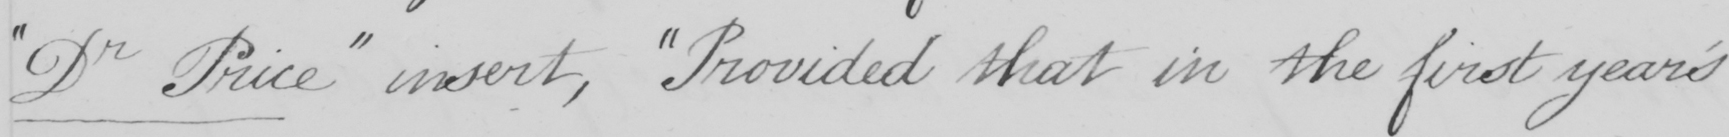What is written in this line of handwriting? " Dr Price "  insert ,  " Provided that in the first year ' s 